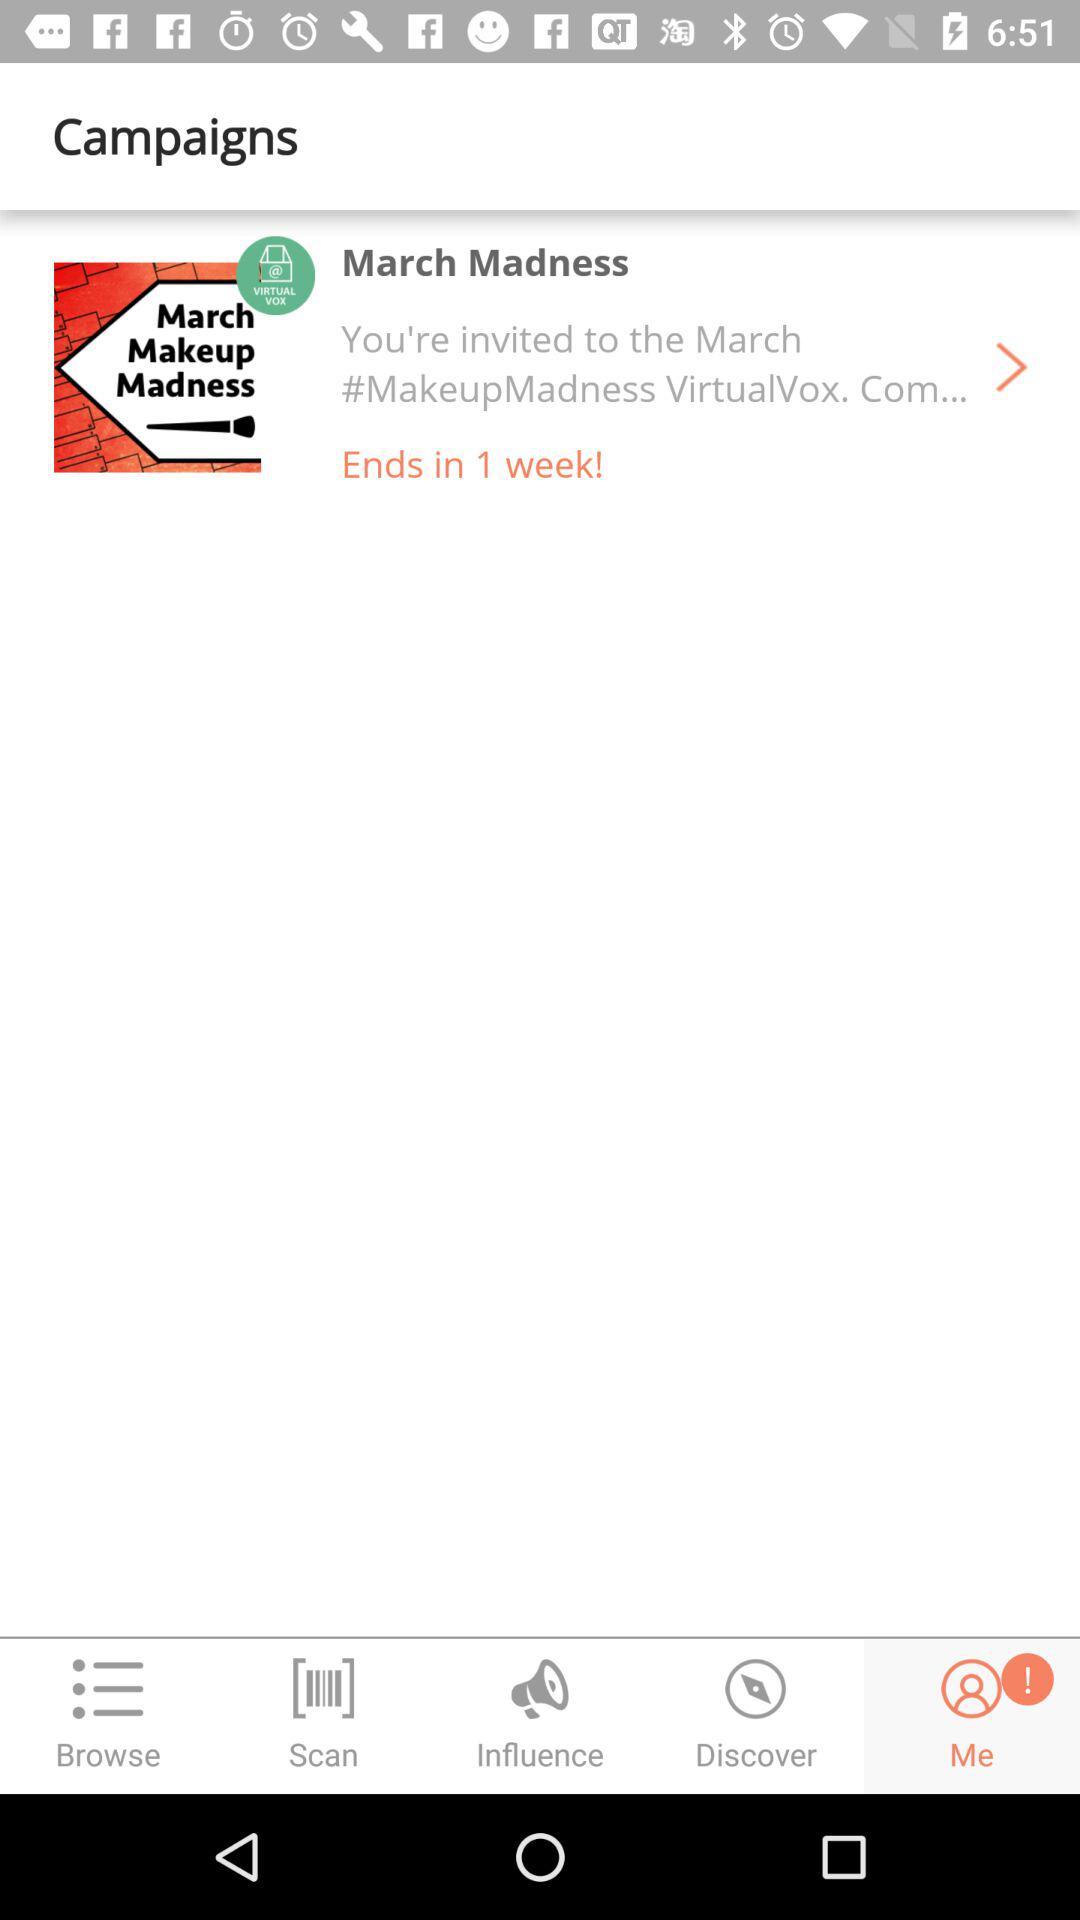What is the duration of the campaign? The campaign ends in one week. 